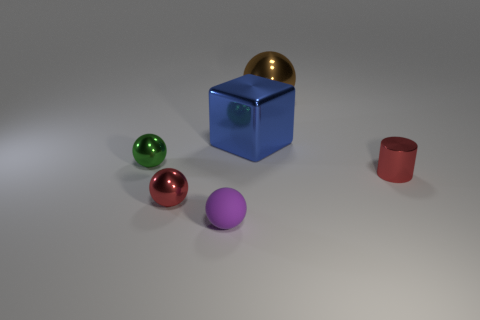Add 3 yellow blocks. How many objects exist? 9 Subtract all cylinders. How many objects are left? 5 Add 5 brown things. How many brown things exist? 6 Subtract 0 purple cylinders. How many objects are left? 6 Subtract all brown metal objects. Subtract all tiny green spheres. How many objects are left? 4 Add 5 metallic blocks. How many metallic blocks are left? 6 